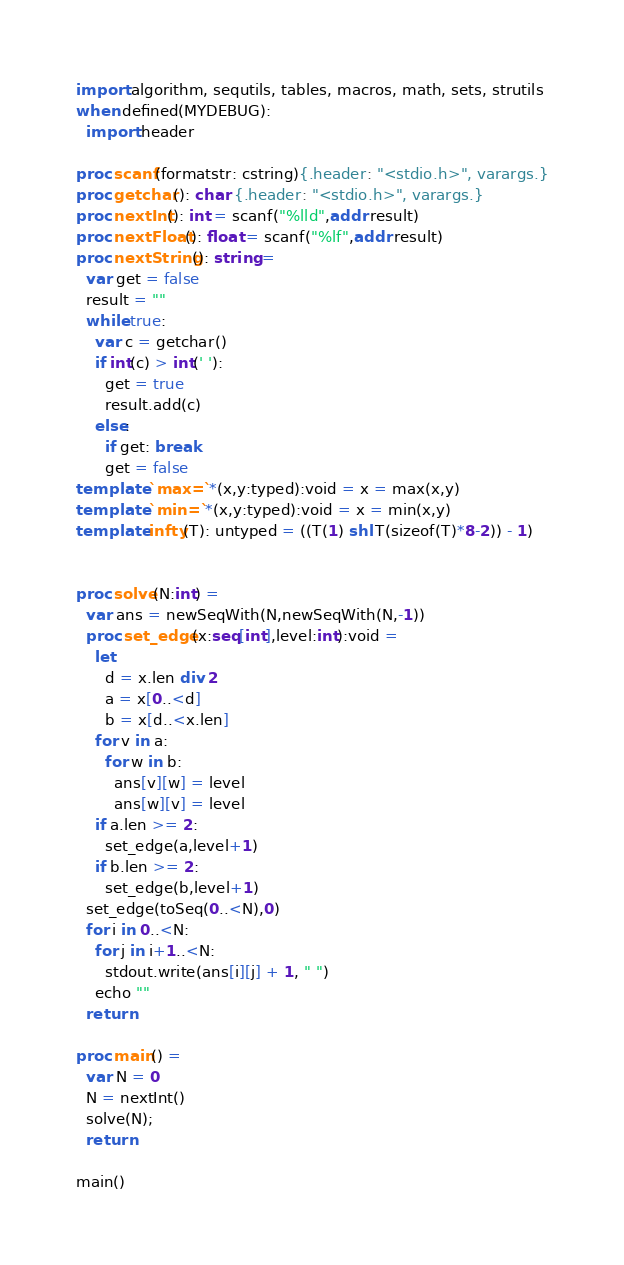<code> <loc_0><loc_0><loc_500><loc_500><_Nim_>import algorithm, sequtils, tables, macros, math, sets, strutils
when defined(MYDEBUG):
  import header

proc scanf(formatstr: cstring){.header: "<stdio.h>", varargs.}
proc getchar(): char {.header: "<stdio.h>", varargs.}
proc nextInt(): int = scanf("%lld",addr result)
proc nextFloat(): float = scanf("%lf",addr result)
proc nextString(): string =
  var get = false
  result = ""
  while true:
    var c = getchar()
    if int(c) > int(' '):
      get = true
      result.add(c)
    else:
      if get: break
      get = false
template `max=`*(x,y:typed):void = x = max(x,y)
template `min=`*(x,y:typed):void = x = min(x,y)
template infty(T): untyped = ((T(1) shl T(sizeof(T)*8-2)) - 1)


proc solve(N:int) =
  var ans = newSeqWith(N,newSeqWith(N,-1))
  proc set_edge(x:seq[int],level:int):void =
    let
      d = x.len div 2
      a = x[0..<d]
      b = x[d..<x.len]
    for v in a:
      for w in b:
        ans[v][w] = level
        ans[w][v] = level
    if a.len >= 2:
      set_edge(a,level+1)
    if b.len >= 2:
      set_edge(b,level+1)
  set_edge(toSeq(0..<N),0)
  for i in 0..<N:
    for j in i+1..<N:
      stdout.write(ans[i][j] + 1, " ")
    echo ""
  return

proc main() =
  var N = 0
  N = nextInt()
  solve(N);
  return

main()</code> 